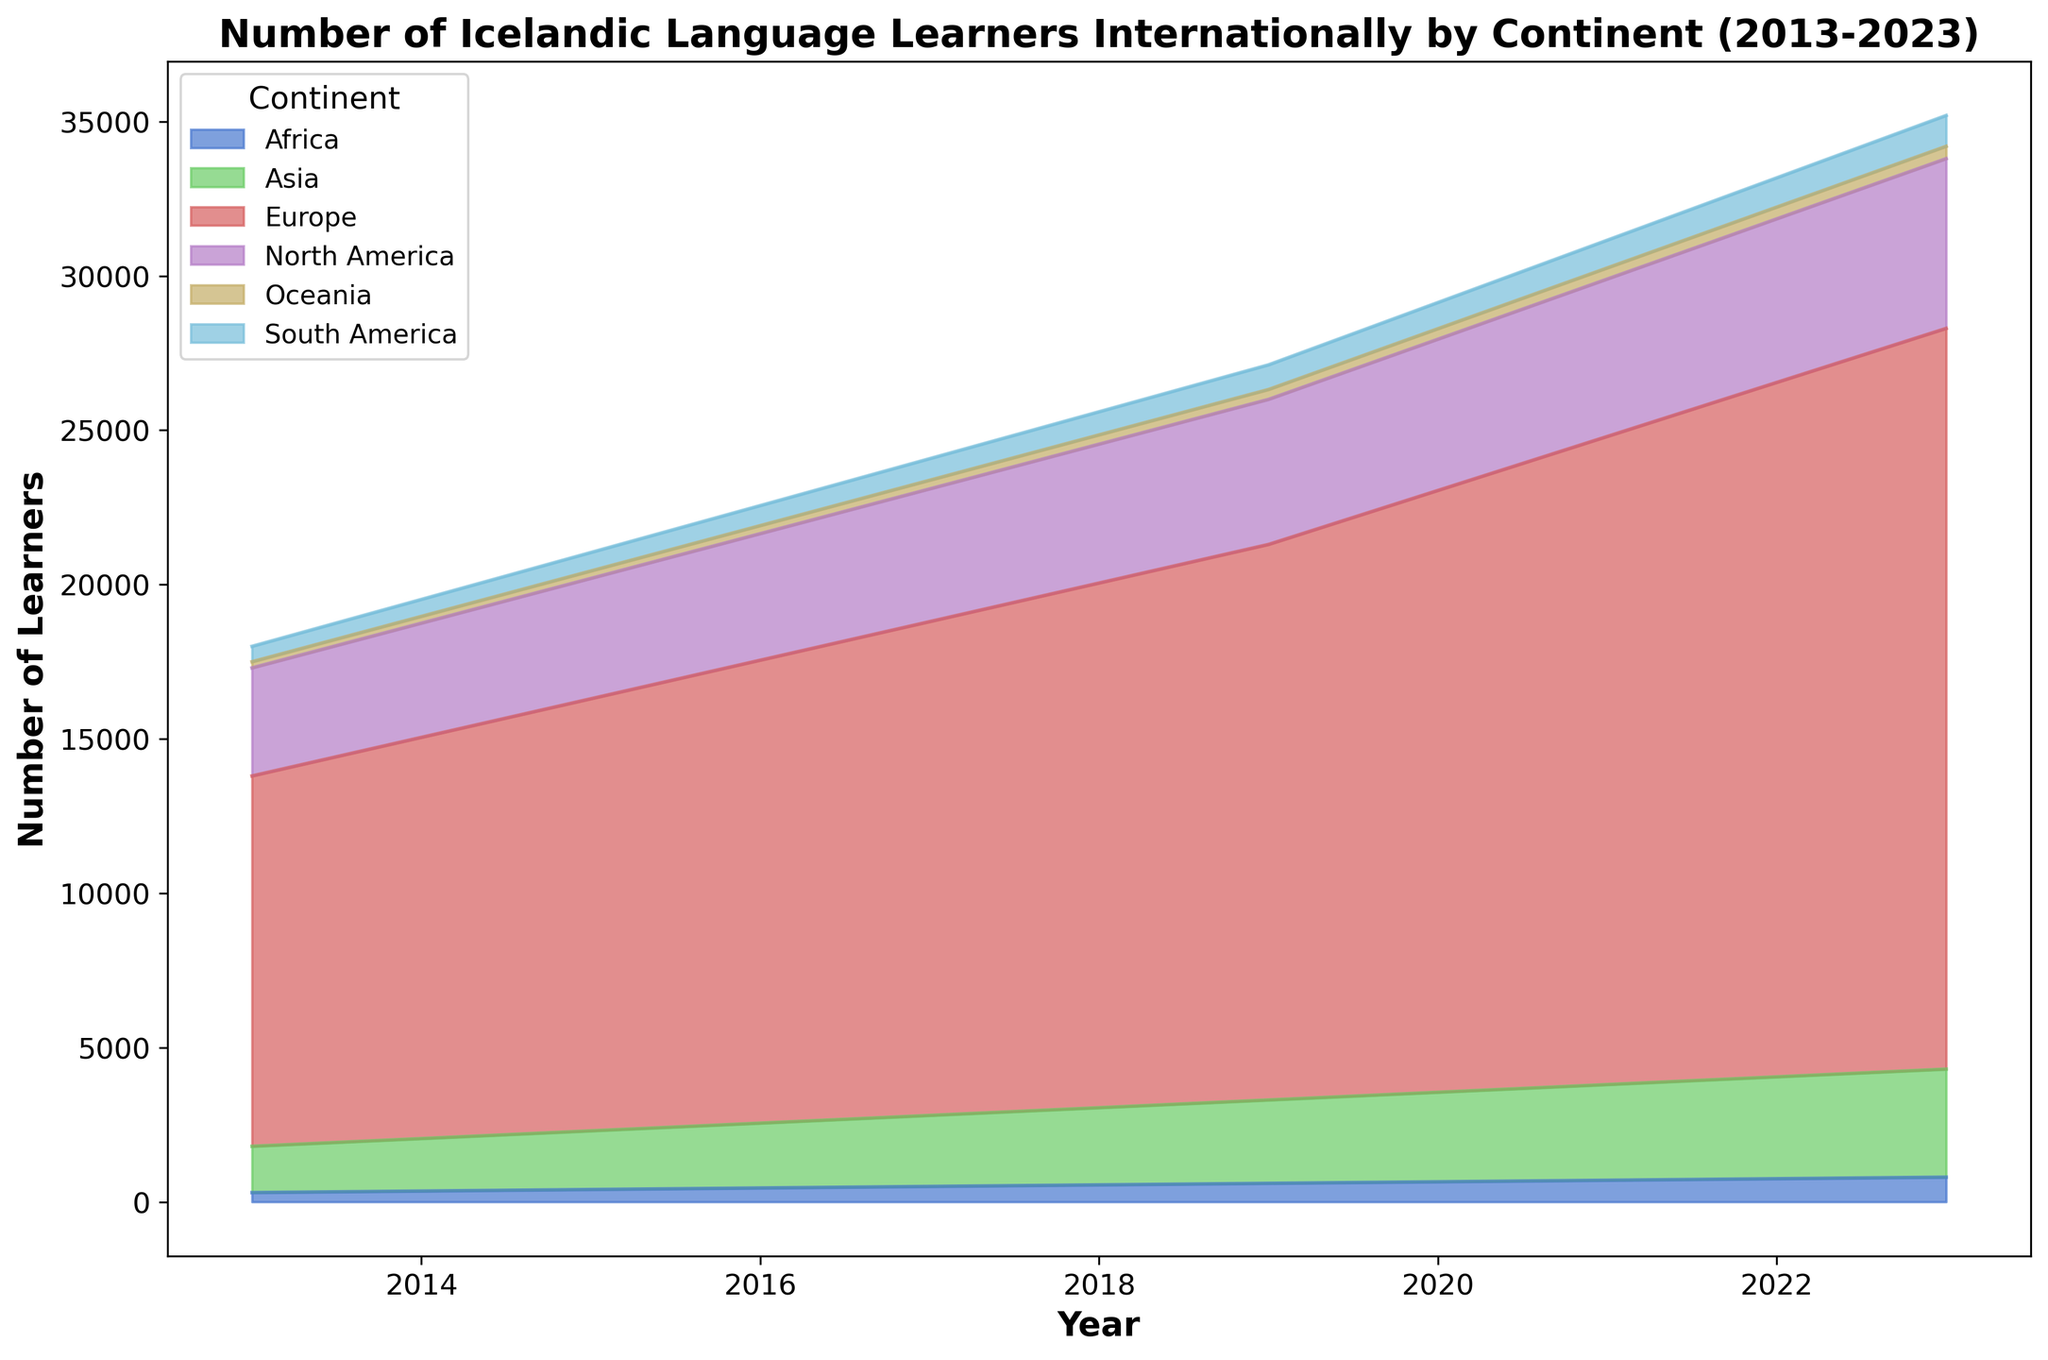Which continent has the highest number of Icelandic language learners in 2023? In 2023, the area for Europe is the largest compared to other continents, indicating it has the highest number of learners.
Answer: Europe How has the number of Icelandic language learners in Asia changed from 2013 to 2023? From 2013 to 2023, the area for Asia has gradually increased, showing a rise in the number of learners from 1500 to 3500.
Answer: Increased Which two continents have the closest number of learners in 2015? In 2015, both Africa and Oceania have the smallest areas among the continents, with the number of learners being 400 and 240, respectively. These areas appear to be more similar compared to other pairs of continents.
Answer: Africa and Oceania By how much did the number of learners in Europe increase from 2018 to 2019? Subtract the number of learners in Europe in 2018 from the number in 2019. (18000 - 17000) gives an increase of 1000 learners.
Answer: 1000 Which continent showed a steady increase in the number of Icelandic language learners every year from 2013 to 2023? Europe shows a consistent increase in its area each year from 2013 to 2023, indicating a steady rise in learners.
Answer: Europe Compare the number of Icelandic learners in North America and South America in 2023. Which continent has more learners and by how much? In 2023, North America has 5500 learners while South America has 1000 learners. Subtracting these values gives 4500 more learners in North America.
Answer: North America, 4500 more What was the total number of Icelandic learners across all continents in 2021? Sum the number of learners from all continents in 2021: (21000 for Europe) + (5100 for North America) + (3100 for Asia) + (900 for South America) + (700 for Africa) + (360 for Oceania) = 31160.
Answer: 31160 In which year did the total number of learners first exceed 25000? In 2020, the combined areas for all continents give a total number of learners of 29590, which is the first year exceeding 25000 learners.
Answer: 2020 What is the average number of learners in Oceania over the entire period from 2013 to 2023? Sum the number of learners in Oceania from 2013 to 2023 and divide by the number of years. (200 + 220 + 240 + 260 + 280 + 300 + 320 + 340 + 360 + 380 + 400) = 3300. Divide 3300 by 11 to get the average number of learners as 300.
Answer: 300 In which year did Africa have more learners than Oceania for the first time? By looking at the relative height of Africa's area above Oceania's area, 2014 marks the year where learners in Africa (350) surpass learners in Oceania (220).
Answer: 2014 